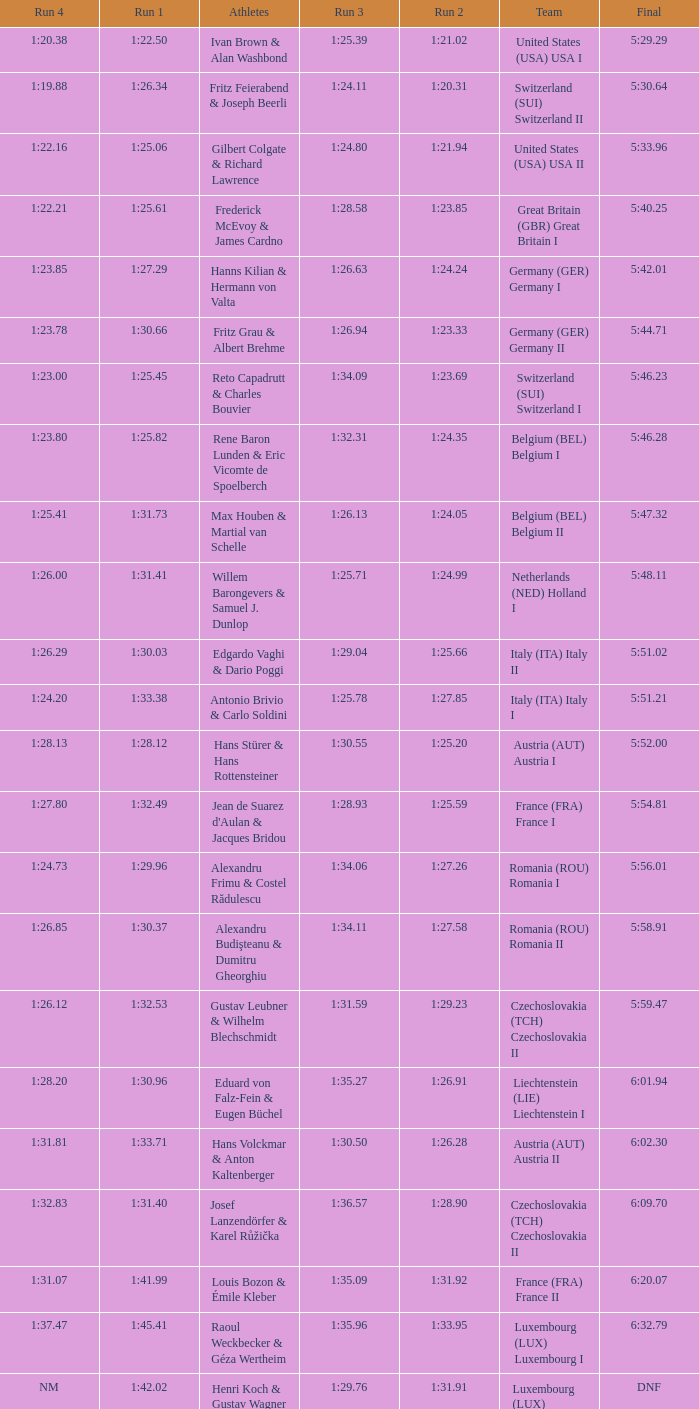Which Run 4 has a Run 1 of 1:25.82? 1:23.80. 